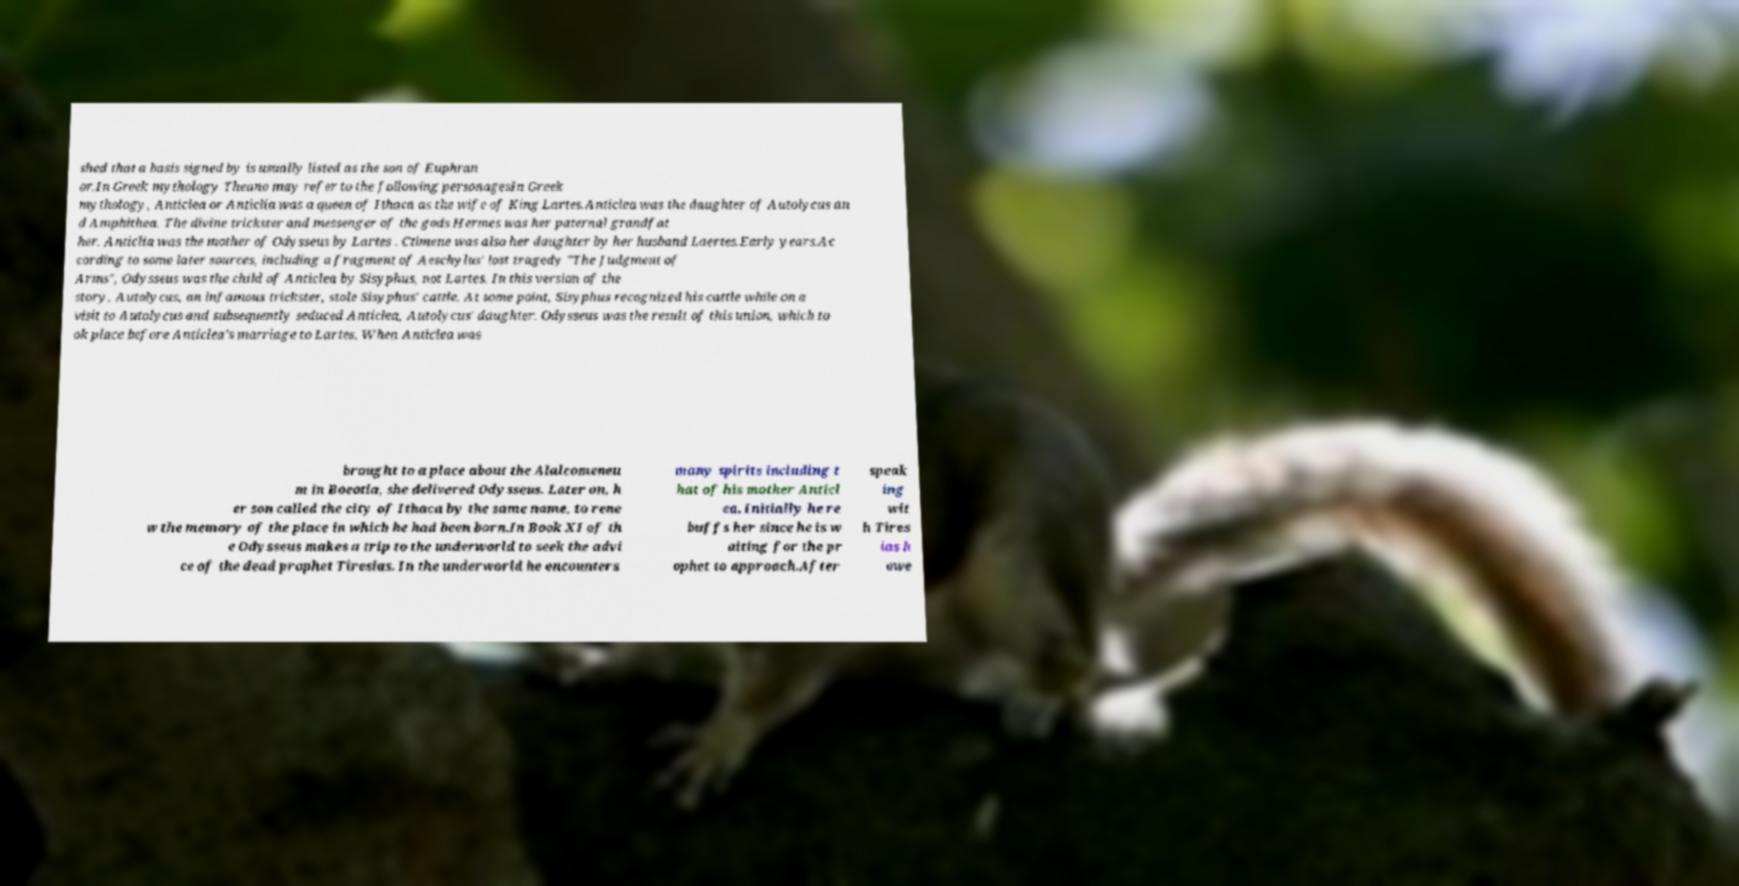What messages or text are displayed in this image? I need them in a readable, typed format. shed that a basis signed by is usually listed as the son of Euphran or.In Greek mythology Theano may refer to the following personagesIn Greek mythology, Anticlea or Anticlia was a queen of Ithaca as the wife of King Lartes.Anticlea was the daughter of Autolycus an d Amphithea. The divine trickster and messenger of the gods Hermes was her paternal grandfat her. Anticlia was the mother of Odysseus by Lartes . Ctimene was also her daughter by her husband Laertes.Early years.Ac cording to some later sources, including a fragment of Aeschylus' lost tragedy "The Judgment of Arms", Odysseus was the child of Anticlea by Sisyphus, not Lartes. In this version of the story, Autolycus, an infamous trickster, stole Sisyphus' cattle. At some point, Sisyphus recognized his cattle while on a visit to Autolycus and subsequently seduced Anticlea, Autolycus' daughter. Odysseus was the result of this union, which to ok place before Anticlea's marriage to Lartes. When Anticlea was brought to a place about the Alalcomeneu m in Boeotia, she delivered Odysseus. Later on, h er son called the city of Ithaca by the same name, to rene w the memory of the place in which he had been born.In Book XI of th e Odysseus makes a trip to the underworld to seek the advi ce of the dead prophet Tiresias. In the underworld he encounters many spirits including t hat of his mother Anticl ea. Initially he re buffs her since he is w aiting for the pr ophet to approach.After speak ing wit h Tires ias h owe 